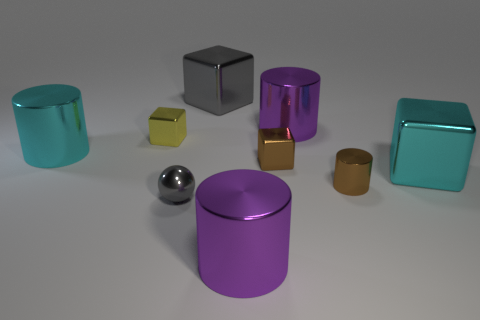How many shiny objects are either cylinders or cyan things?
Provide a short and direct response. 5. What is the material of the purple thing that is on the right side of the big purple cylinder that is in front of the brown cylinder?
Ensure brevity in your answer.  Metal. What is the shape of the tiny metallic object that is the same color as the small cylinder?
Provide a short and direct response. Cube. There is a gray object that is the same size as the yellow metallic thing; what shape is it?
Your response must be concise. Sphere. Is the number of purple metal objects less than the number of small yellow metal objects?
Your response must be concise. No. Are there any big cyan shiny cubes behind the cyan thing that is behind the cyan metallic cube?
Give a very brief answer. No. What shape is the big gray object that is made of the same material as the brown block?
Keep it short and to the point. Cube. Is there any other thing of the same color as the tiny cylinder?
Provide a succinct answer. Yes. What is the material of the other small object that is the same shape as the yellow object?
Give a very brief answer. Metal. What number of other objects are the same size as the brown metal cylinder?
Make the answer very short. 3. 